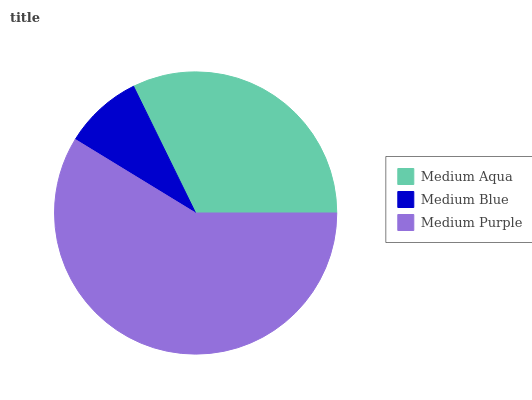Is Medium Blue the minimum?
Answer yes or no. Yes. Is Medium Purple the maximum?
Answer yes or no. Yes. Is Medium Purple the minimum?
Answer yes or no. No. Is Medium Blue the maximum?
Answer yes or no. No. Is Medium Purple greater than Medium Blue?
Answer yes or no. Yes. Is Medium Blue less than Medium Purple?
Answer yes or no. Yes. Is Medium Blue greater than Medium Purple?
Answer yes or no. No. Is Medium Purple less than Medium Blue?
Answer yes or no. No. Is Medium Aqua the high median?
Answer yes or no. Yes. Is Medium Aqua the low median?
Answer yes or no. Yes. Is Medium Purple the high median?
Answer yes or no. No. Is Medium Blue the low median?
Answer yes or no. No. 